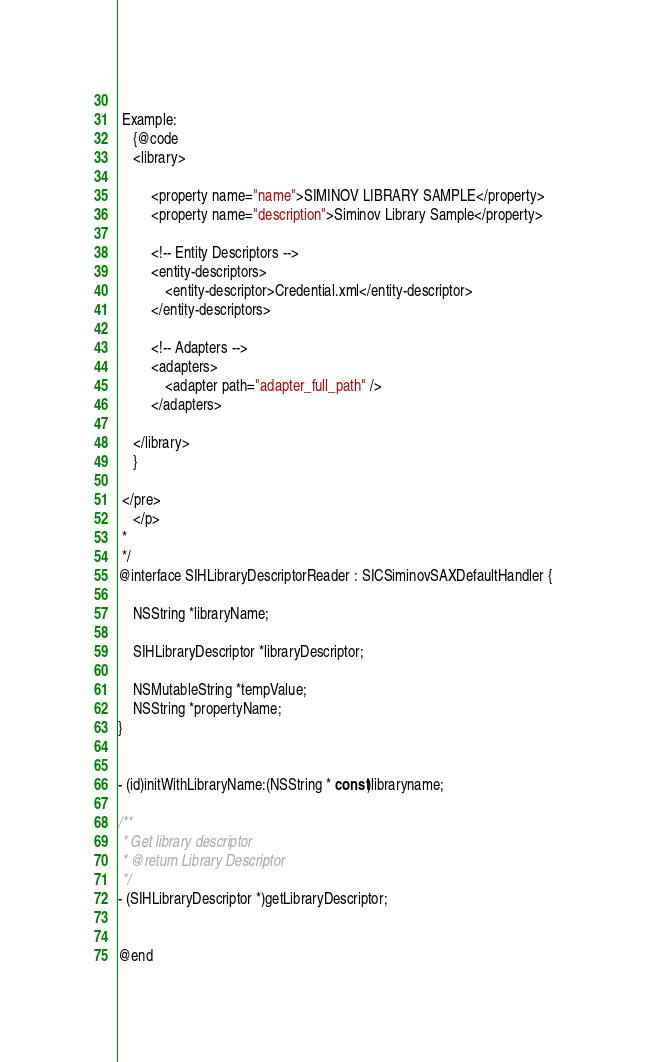<code> <loc_0><loc_0><loc_500><loc_500><_C_> 
 Example:
	{@code
	<library>
 
         <property name="name">SIMINOV LIBRARY SAMPLE</property>
         <property name="description">Siminov Library Sample</property>
            
         <!-- Entity Descriptors -->
         <entity-descriptors>
             <entity-descriptor>Credential.xml</entity-descriptor>
         </entity-descriptors>
            
         <!-- Adapters -->
         <adapters>
             <adapter path="adapter_full_path" />
         </adapters>
 
	</library>
	}
	
 </pre>
	</p>
 *
 */
@interface SIHLibraryDescriptorReader : SICSiminovSAXDefaultHandler {
    
    NSString *libraryName;
    
    SIHLibraryDescriptor *libraryDescriptor;
    
    NSMutableString *tempValue;
    NSString *propertyName;
}


- (id)initWithLibraryName:(NSString * const)libraryname;

/**
 * Get library descriptor
 * @return Library Descriptor
 */
- (SIHLibraryDescriptor *)getLibraryDescriptor;


@end
</code> 